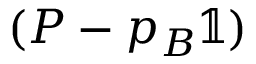Convert formula to latex. <formula><loc_0><loc_0><loc_500><loc_500>( P - p _ { B } \mathbb { 1 } )</formula> 